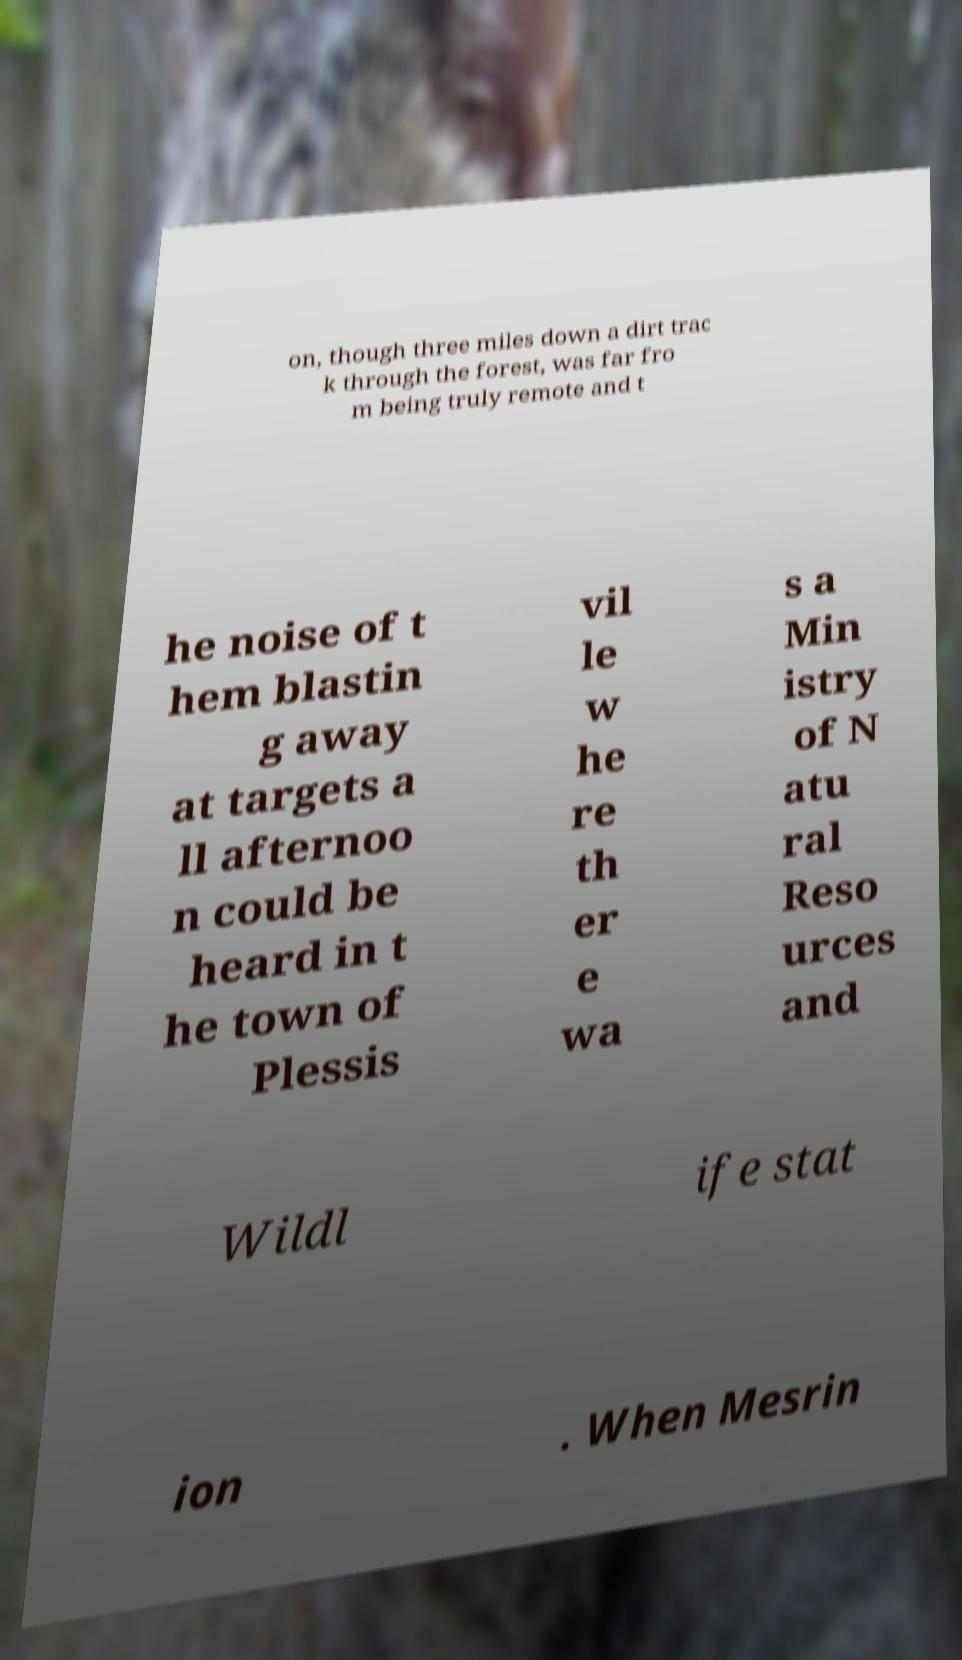Please identify and transcribe the text found in this image. on, though three miles down a dirt trac k through the forest, was far fro m being truly remote and t he noise of t hem blastin g away at targets a ll afternoo n could be heard in t he town of Plessis vil le w he re th er e wa s a Min istry of N atu ral Reso urces and Wildl ife stat ion . When Mesrin 